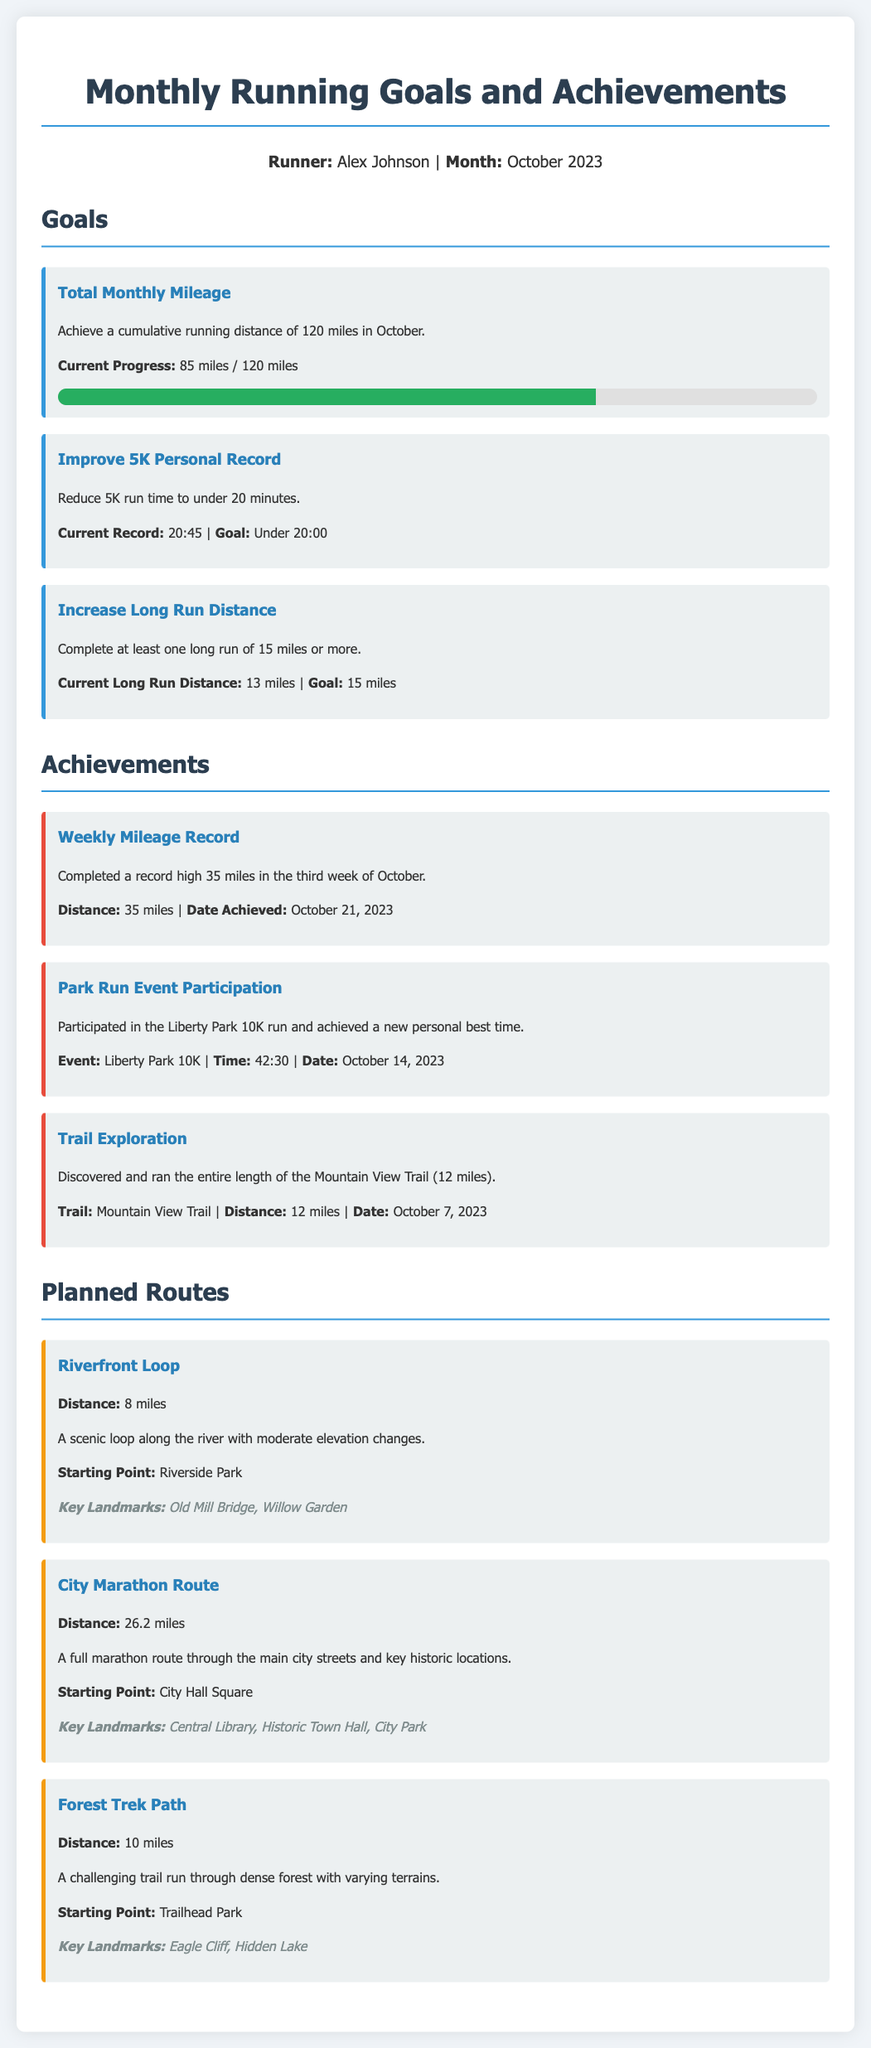What is the total monthly mileage goal? The document states that the cumulative running distance goal for October is 120 miles.
Answer: 120 miles What is the current long run distance? The document indicates that the current long run distance is 13 miles, with a goal of 15 miles.
Answer: 13 miles Who is the runner mentioned in the document? The runner's name is stated in the runner info section of the document.
Answer: Alex Johnson What is the date of the weekly mileage record achievement? The document provides the date when the record high mileage was achieved, which is indicated.
Answer: October 21, 2023 What is the distance of the Riverfront Loop route? The document specifies the distance of the Riverfront Loop in the planned routes section.
Answer: 8 miles What is the goal for the 5K personal record? The document outlines the target time for the 5K personal record, indicating the runner's goal.
Answer: Under 20:00 Which event did the runner participate in? The document lists a specific event where the runner participated and achieved a personal best.
Answer: Liberty Park 10K What is the current progress towards the total monthly mileage goal? The document includes the current progress towards the monthly mileage goal, showing how much the runner has completed.
Answer: 85 miles / 120 miles What is the distance of the City Marathon Route? The document states the distance of the City Marathon Route in the planned routes section.
Answer: 26.2 miles 